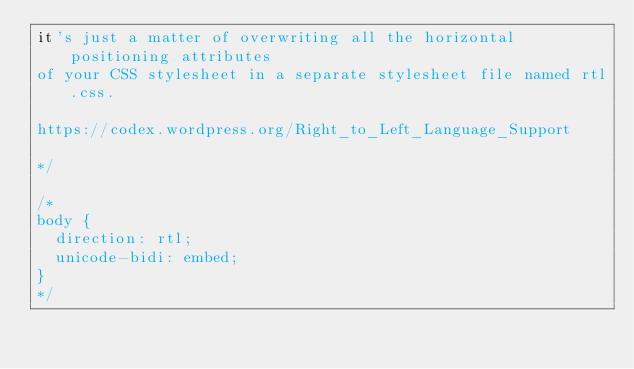Convert code to text. <code><loc_0><loc_0><loc_500><loc_500><_CSS_>it's just a matter of overwriting all the horizontal positioning attributes
of your CSS stylesheet in a separate stylesheet file named rtl.css.

https://codex.wordpress.org/Right_to_Left_Language_Support

*/

/*
body {
	direction: rtl;
	unicode-bidi: embed;
}
*/</code> 